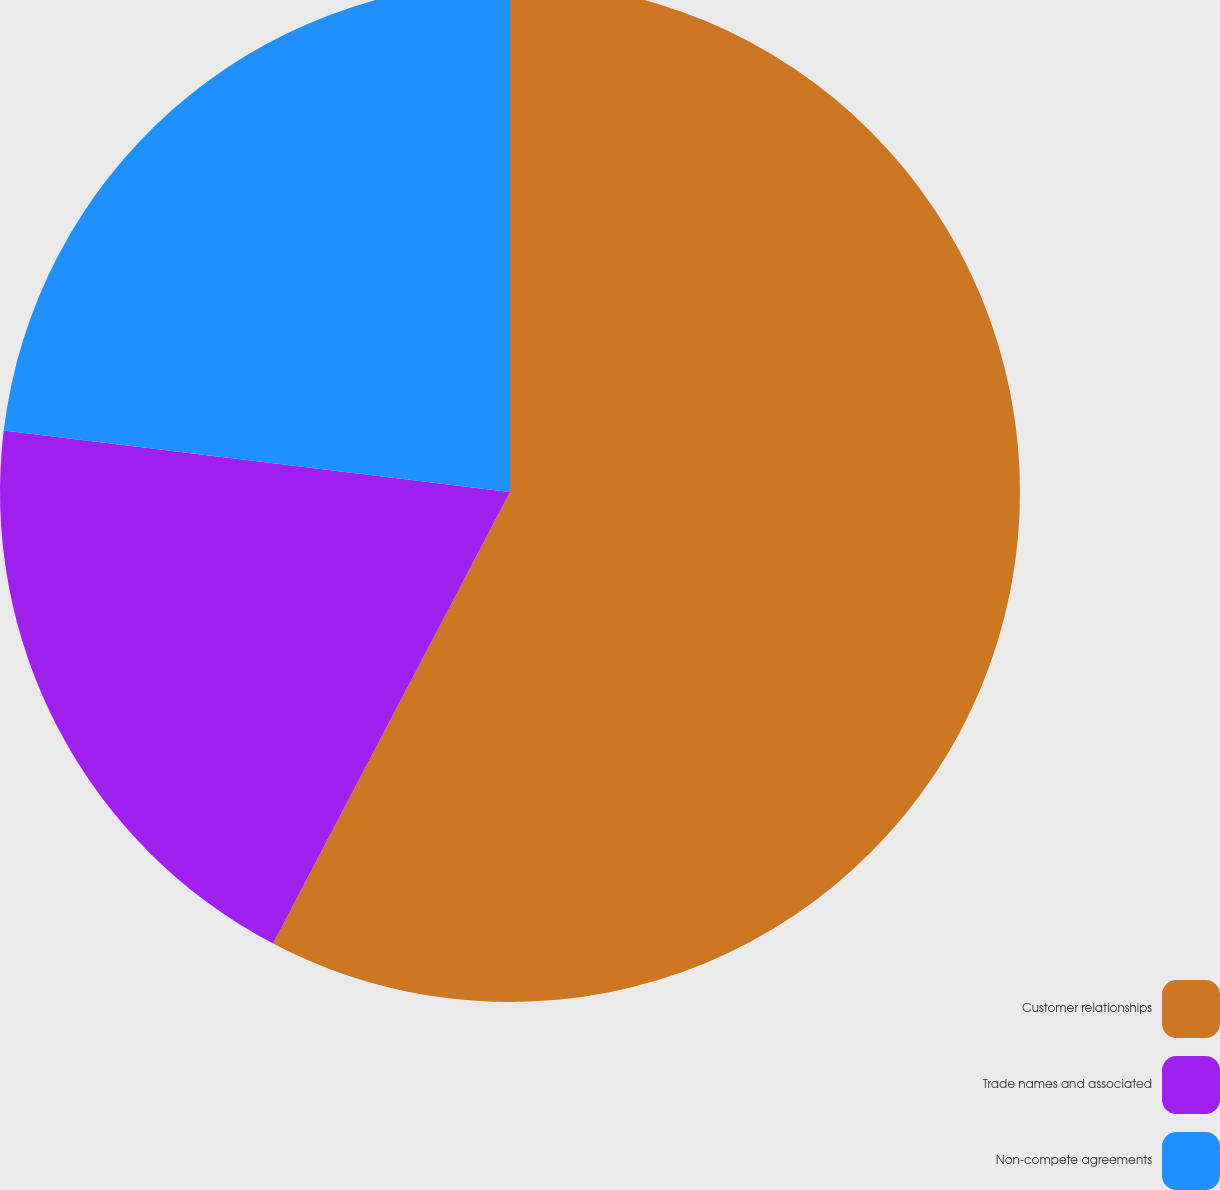Convert chart. <chart><loc_0><loc_0><loc_500><loc_500><pie_chart><fcel>Customer relationships<fcel>Trade names and associated<fcel>Non-compete agreements<nl><fcel>57.69%<fcel>19.23%<fcel>23.08%<nl></chart> 